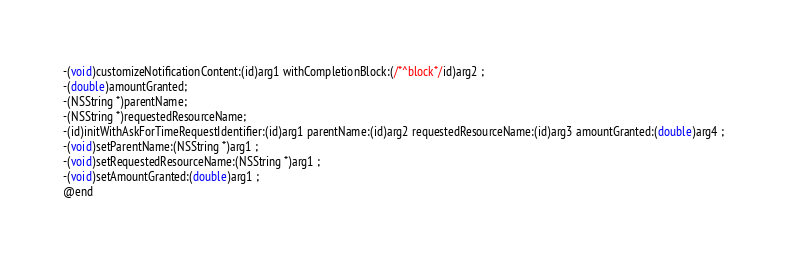<code> <loc_0><loc_0><loc_500><loc_500><_C_>-(void)customizeNotificationContent:(id)arg1 withCompletionBlock:(/*^block*/id)arg2 ;
-(double)amountGranted;
-(NSString *)parentName;
-(NSString *)requestedResourceName;
-(id)initWithAskForTimeRequestIdentifier:(id)arg1 parentName:(id)arg2 requestedResourceName:(id)arg3 amountGranted:(double)arg4 ;
-(void)setParentName:(NSString *)arg1 ;
-(void)setRequestedResourceName:(NSString *)arg1 ;
-(void)setAmountGranted:(double)arg1 ;
@end

</code> 